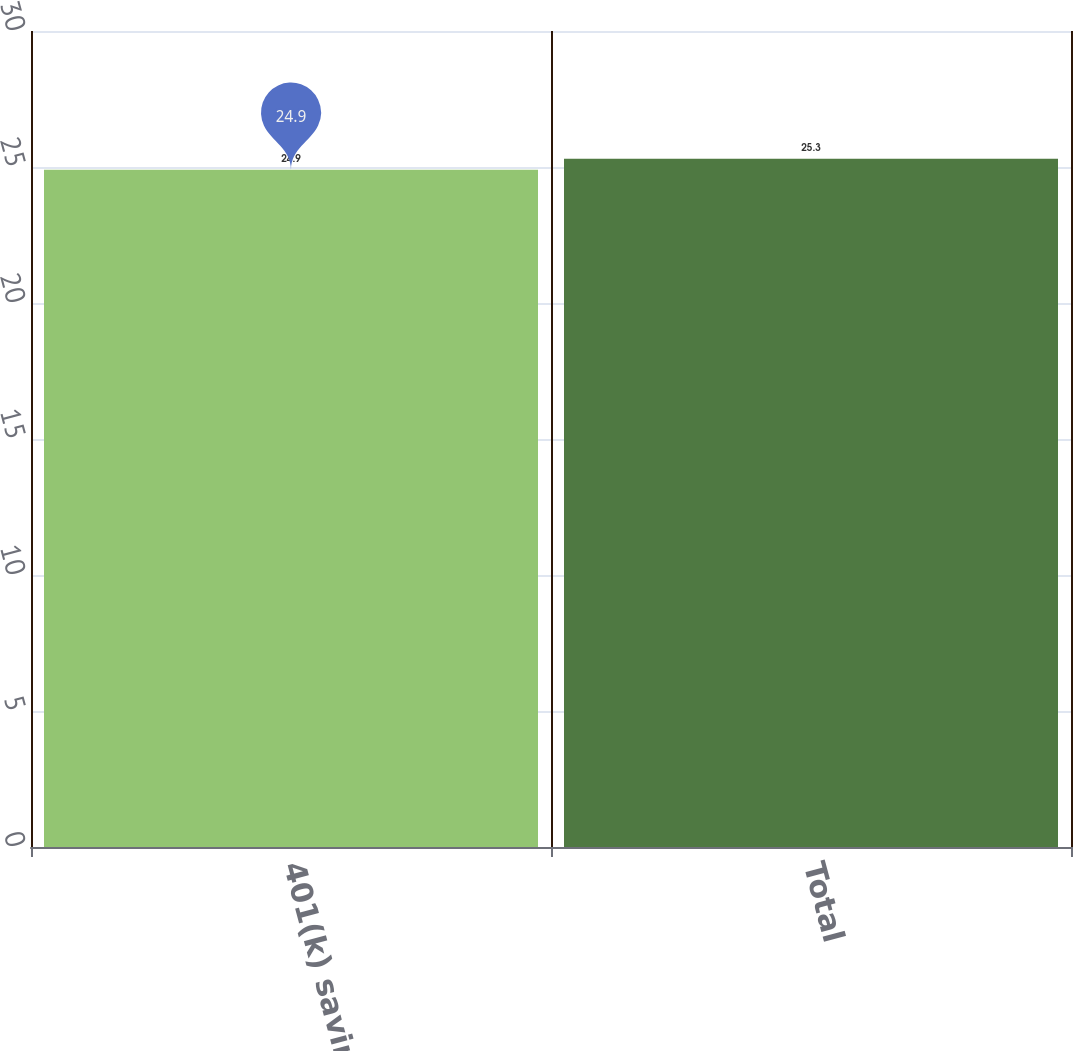Convert chart. <chart><loc_0><loc_0><loc_500><loc_500><bar_chart><fcel>401(k) savings plan<fcel>Total<nl><fcel>24.9<fcel>25.3<nl></chart> 